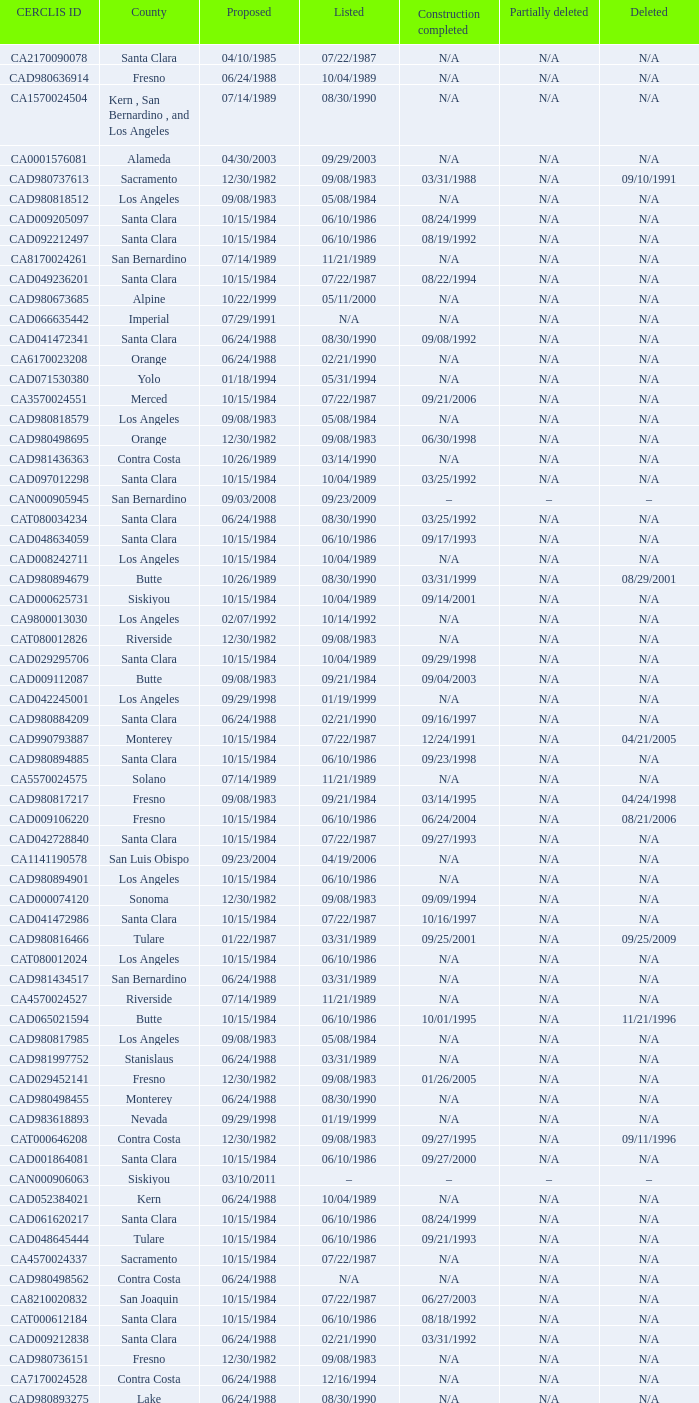What construction completed on 08/10/2007? 07/22/1987. 